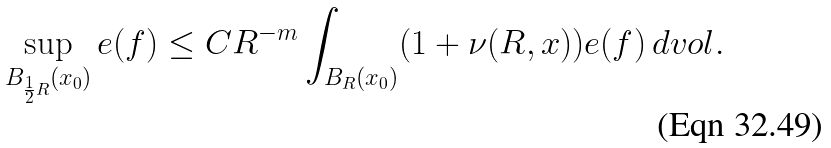<formula> <loc_0><loc_0><loc_500><loc_500>\sup _ { B _ { \frac { 1 } { 2 } R } ( x _ { 0 } ) } e ( f ) \leq C R ^ { - m } \int _ { B _ { R } ( x _ { 0 } ) } ( 1 + \nu ( R , x ) ) e ( f ) \, d v o l .</formula> 